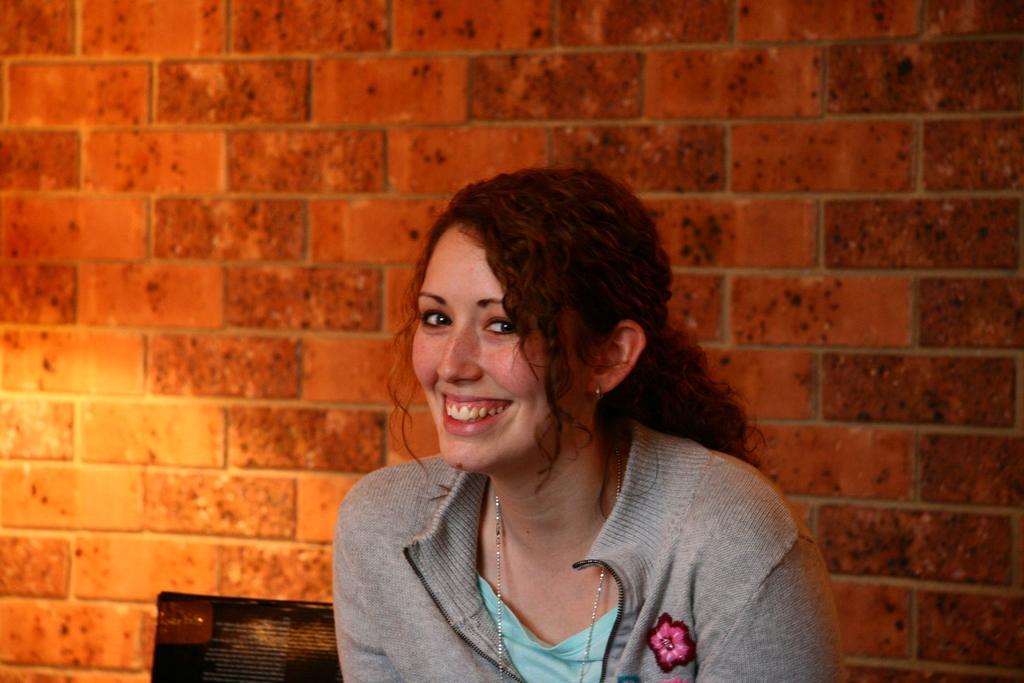Could you give a brief overview of what you see in this image? In this image I can see a person sitting wearing green and gray color dress. Background I can see wall in brown color. 